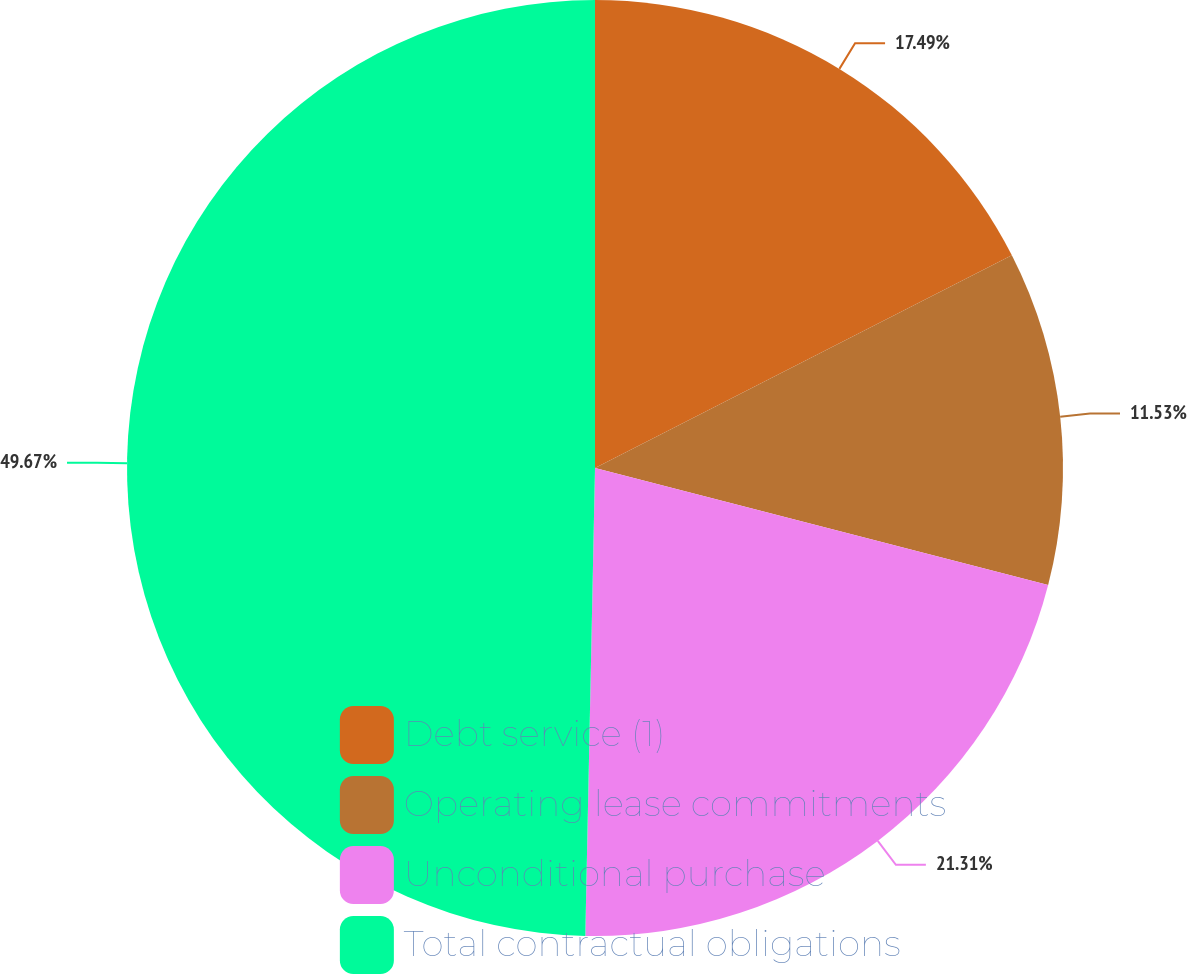<chart> <loc_0><loc_0><loc_500><loc_500><pie_chart><fcel>Debt service (1)<fcel>Operating lease commitments<fcel>Unconditional purchase<fcel>Total contractual obligations<nl><fcel>17.49%<fcel>11.53%<fcel>21.31%<fcel>49.67%<nl></chart> 